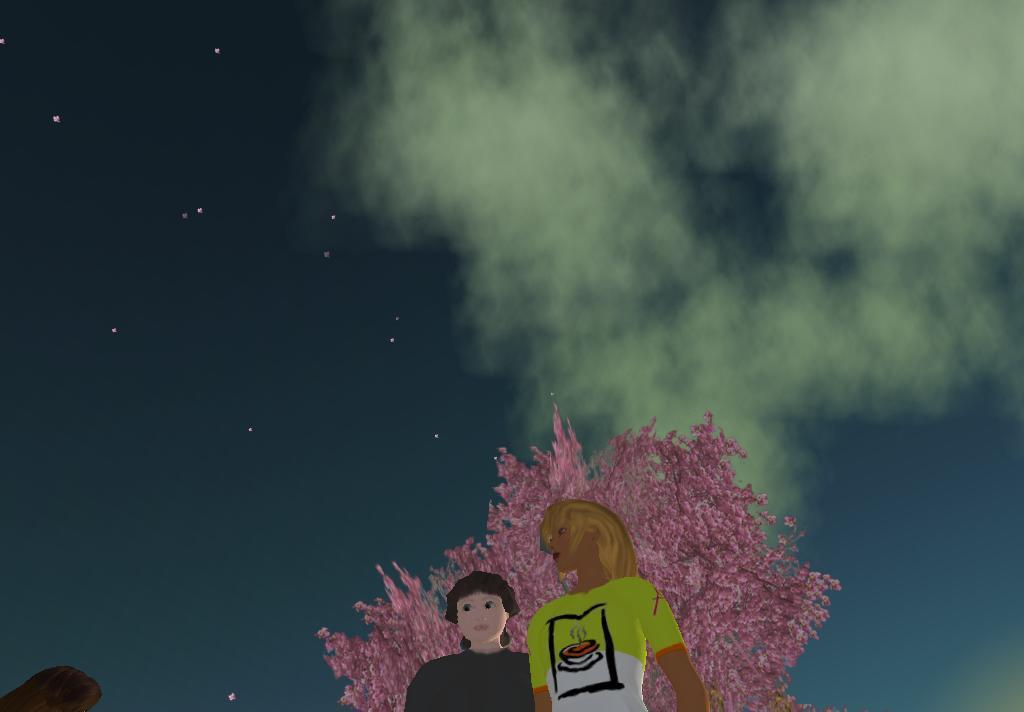Describe this image in one or two sentences. In this image we can see an animation pictures, at back here is the tree, it is in pink color, at above here is the sky, here are the stars. 